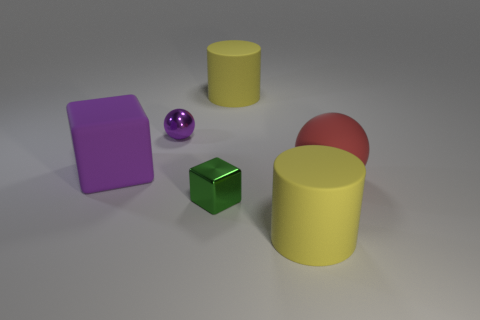Is the cylinder that is in front of the tiny sphere made of the same material as the large yellow cylinder behind the large purple matte block?
Keep it short and to the point. Yes. How many green metallic things have the same size as the purple cube?
Your answer should be very brief. 0. Are there fewer purple metallic cylinders than purple balls?
Your response must be concise. Yes. What is the shape of the big yellow object that is right of the yellow cylinder behind the big red ball?
Your answer should be very brief. Cylinder. What shape is the green metallic object that is the same size as the purple shiny object?
Your answer should be compact. Cube. Are there any metallic objects that have the same shape as the red rubber object?
Ensure brevity in your answer.  Yes. What is the material of the green cube?
Your response must be concise. Metal. There is a red sphere; are there any cylinders behind it?
Your answer should be compact. Yes. There is a metallic thing in front of the large red rubber sphere; how many big purple matte things are behind it?
Make the answer very short. 1. What is the material of the ball that is the same size as the purple rubber block?
Offer a terse response. Rubber. 